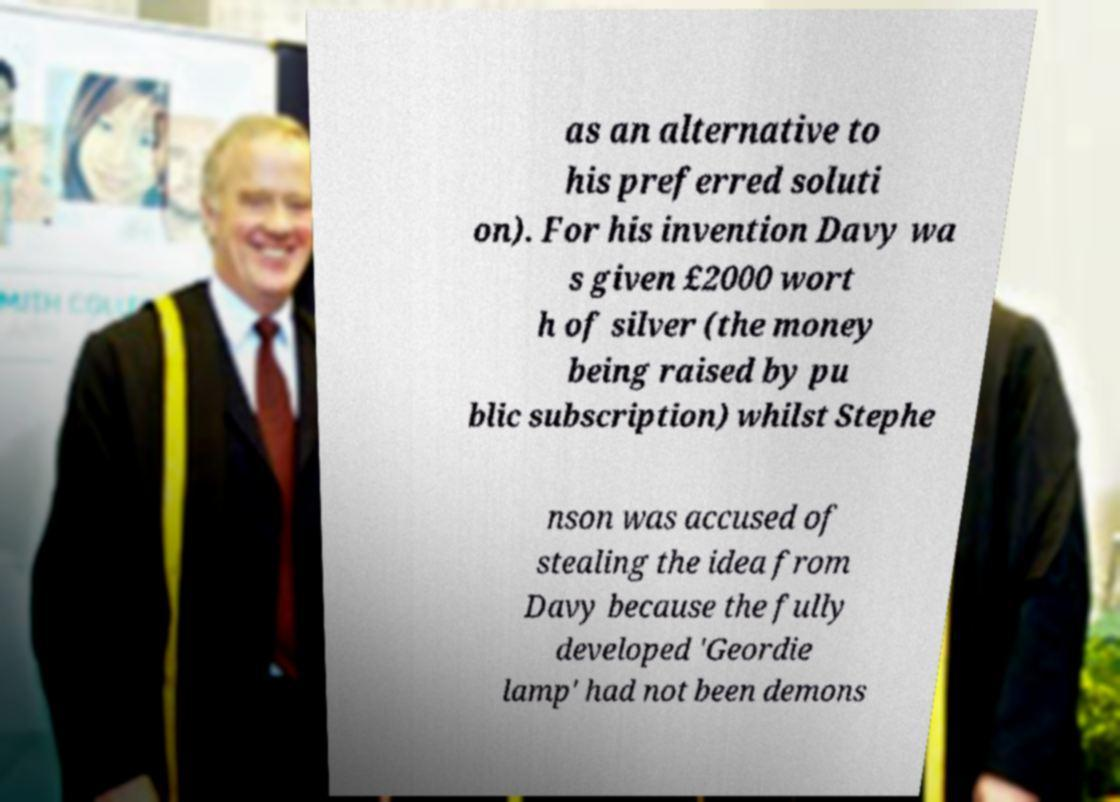Can you accurately transcribe the text from the provided image for me? as an alternative to his preferred soluti on). For his invention Davy wa s given £2000 wort h of silver (the money being raised by pu blic subscription) whilst Stephe nson was accused of stealing the idea from Davy because the fully developed 'Geordie lamp' had not been demons 